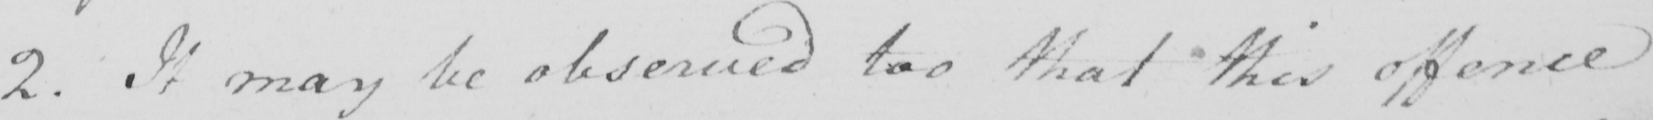What is written in this line of handwriting? 2 . It may be observed too that this offence 